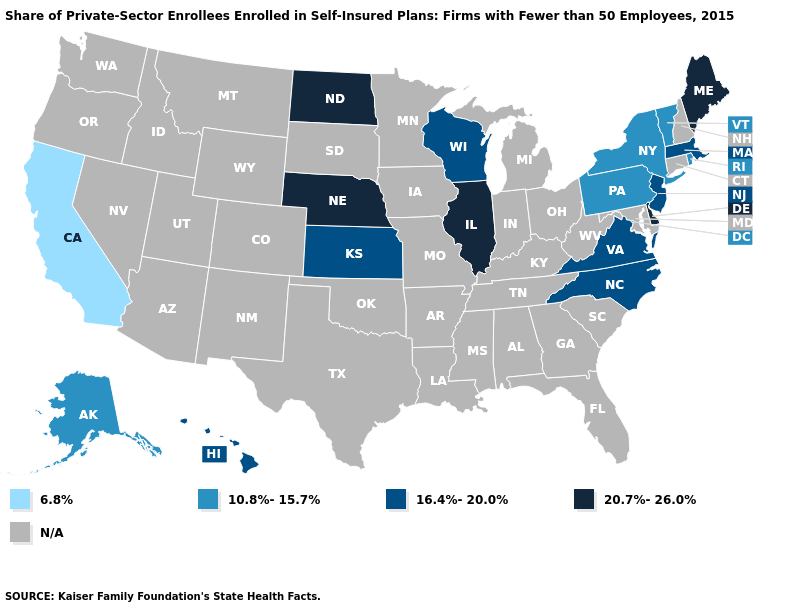Does Virginia have the highest value in the South?
Answer briefly. No. What is the value of Virginia?
Keep it brief. 16.4%-20.0%. What is the value of Mississippi?
Concise answer only. N/A. What is the highest value in the USA?
Answer briefly. 20.7%-26.0%. Which states have the highest value in the USA?
Be succinct. Delaware, Illinois, Maine, Nebraska, North Dakota. How many symbols are there in the legend?
Answer briefly. 5. Name the states that have a value in the range 20.7%-26.0%?
Write a very short answer. Delaware, Illinois, Maine, Nebraska, North Dakota. Does Delaware have the highest value in the USA?
Keep it brief. Yes. Name the states that have a value in the range 20.7%-26.0%?
Keep it brief. Delaware, Illinois, Maine, Nebraska, North Dakota. Which states have the highest value in the USA?
Short answer required. Delaware, Illinois, Maine, Nebraska, North Dakota. What is the value of Maine?
Short answer required. 20.7%-26.0%. Name the states that have a value in the range 20.7%-26.0%?
Give a very brief answer. Delaware, Illinois, Maine, Nebraska, North Dakota. Which states have the lowest value in the Northeast?
Quick response, please. New York, Pennsylvania, Rhode Island, Vermont. 